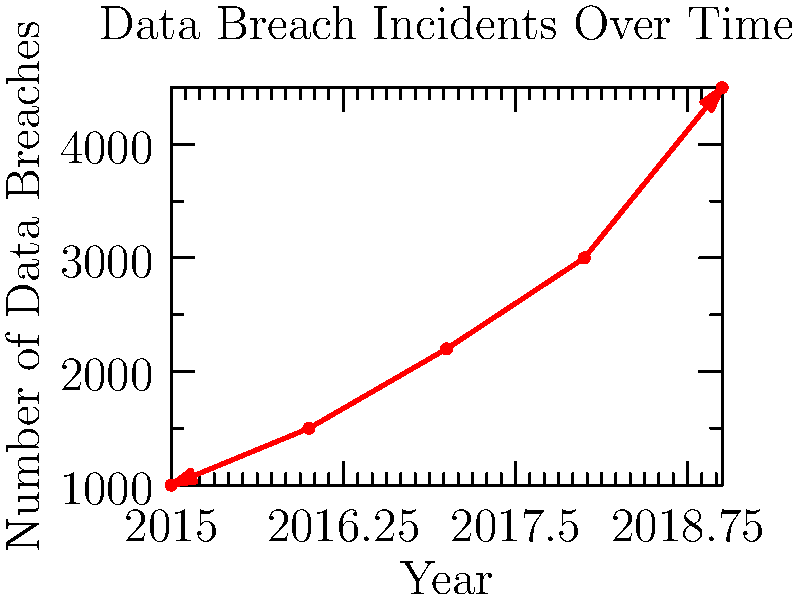Based on the line graph showing the number of data breach incidents from 2015 to 2019, what can be concluded about the trend of data breaches in recent years? How might this trend impact business operations and decision-making for a corporate executive? To answer this question, let's analyze the graph step-by-step:

1. Observe the overall trend: The line graph shows a clear upward trend from 2015 to 2019.

2. Quantify the increase:
   - In 2015, there were approximately 1,000 data breaches.
   - By 2019, this number had increased to about 4,500 data breaches.

3. Calculate the growth rate:
   - Total increase: 4,500 - 1,000 = 3,500
   - Percentage increase: (3,500 / 1,000) * 100 = 350% over 4 years

4. Analyze the year-over-year growth:
   - The line becomes steeper each year, indicating accelerating growth.

5. Impact on business operations:
   - Increased cybersecurity risks
   - Potential for significant financial losses
   - Damage to company reputation
   - Need for increased investment in cybersecurity measures

6. Impact on executive decision-making:
   - Prioritize cybersecurity in budget allocation
   - Implement more robust data protection policies
   - Invest in employee training on data security
   - Consider cyber insurance options

Conclusion: The trend shows a rapidly increasing number of data breaches, which poses a significant and growing threat to businesses. Corporate executives need to take proactive measures to protect their organizations from this escalating risk.
Answer: Rapidly increasing trend; requires prioritizing cybersecurity measures and investments. 